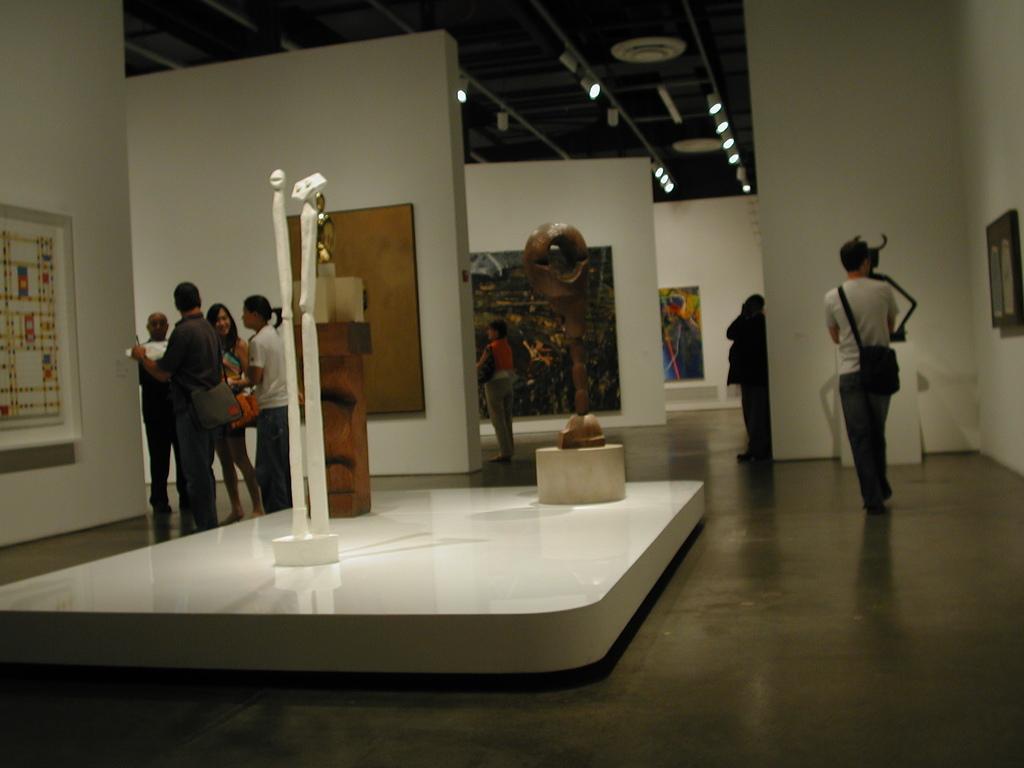Please provide a concise description of this image. In this image we can see the persons standing on the floor. And there are frames attached to the wall. There are statues on the white color surface. At the top there is the ceiling with lights. 